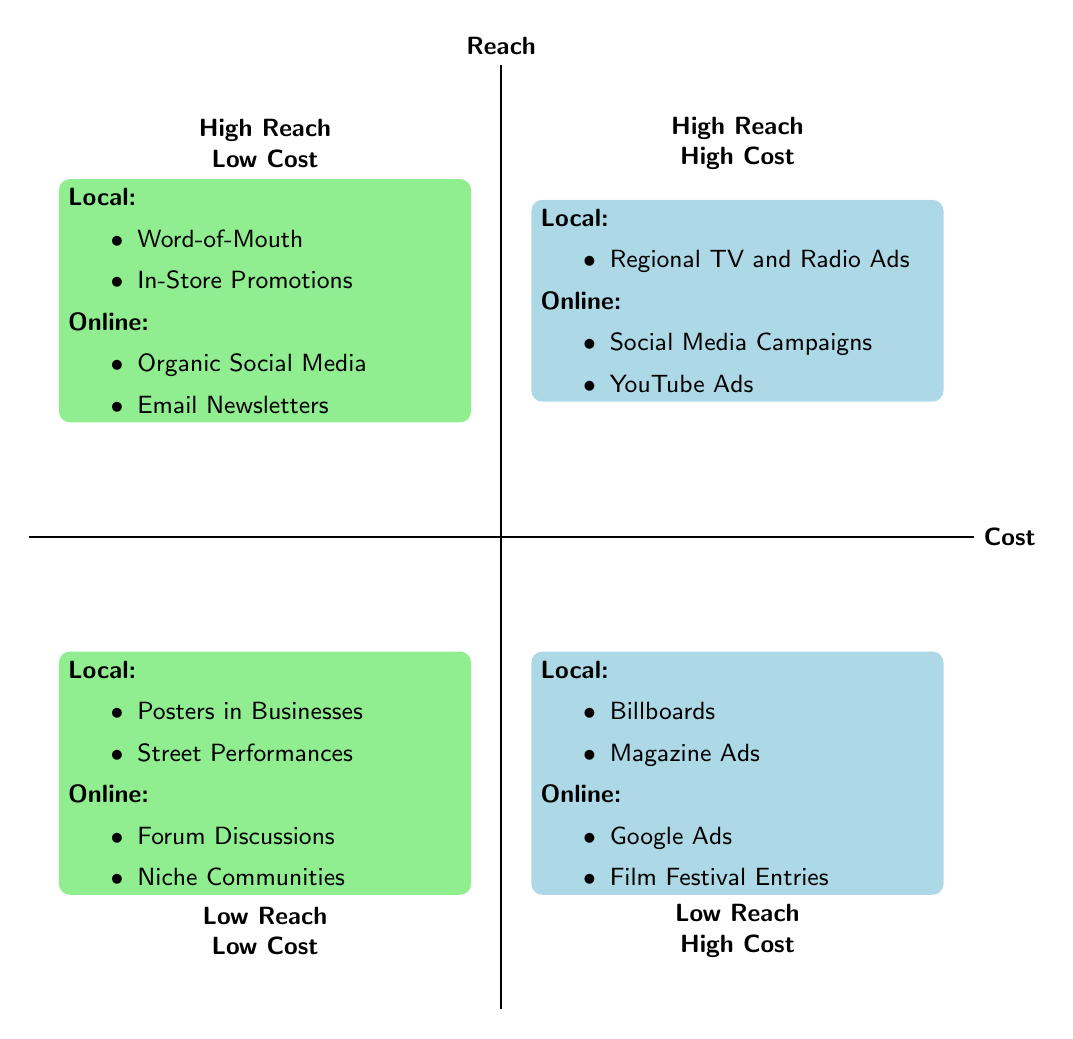What strategies are in the high reach, high cost quadrant for local distribution? The diagram shows that in the high reach, high cost quadrant for local distribution there is one strategy: Regional TV and Radio Ads.
Answer: Regional TV and Radio Ads How many strategies are categorized under low reach, low cost for online distribution? In the low reach, low cost quadrant for online distribution, there are two strategies: Targeted Forum Discussions and Niche Online Communities. Therefore, the count is 2.
Answer: 2 Which quadrant contains both low cost and high reach strategies for online distribution? The quadrant that contains both low cost and high reach strategies for online distribution is the top left quadrant. It lists Organic Social Media and Email Newsletters.
Answer: Top left What type of reach do billboards fall under in the diagram? Billboards are listed in the low reach, high cost quadrant for local distribution.
Answer: Low reach Which local video store strategy is shared with online distribution in the high reach, low cost category? The shared strategy in this category for both local and online is Word-of-Mouth.
Answer: Word-of-Mouth What are the two strategies found in the high reach, low cost quadrant for local video stores? The two strategies listed in this quadrant are Word-of-Mouth and In-Store Promotions.
Answer: Word-of-Mouth, In-Store Promotions 